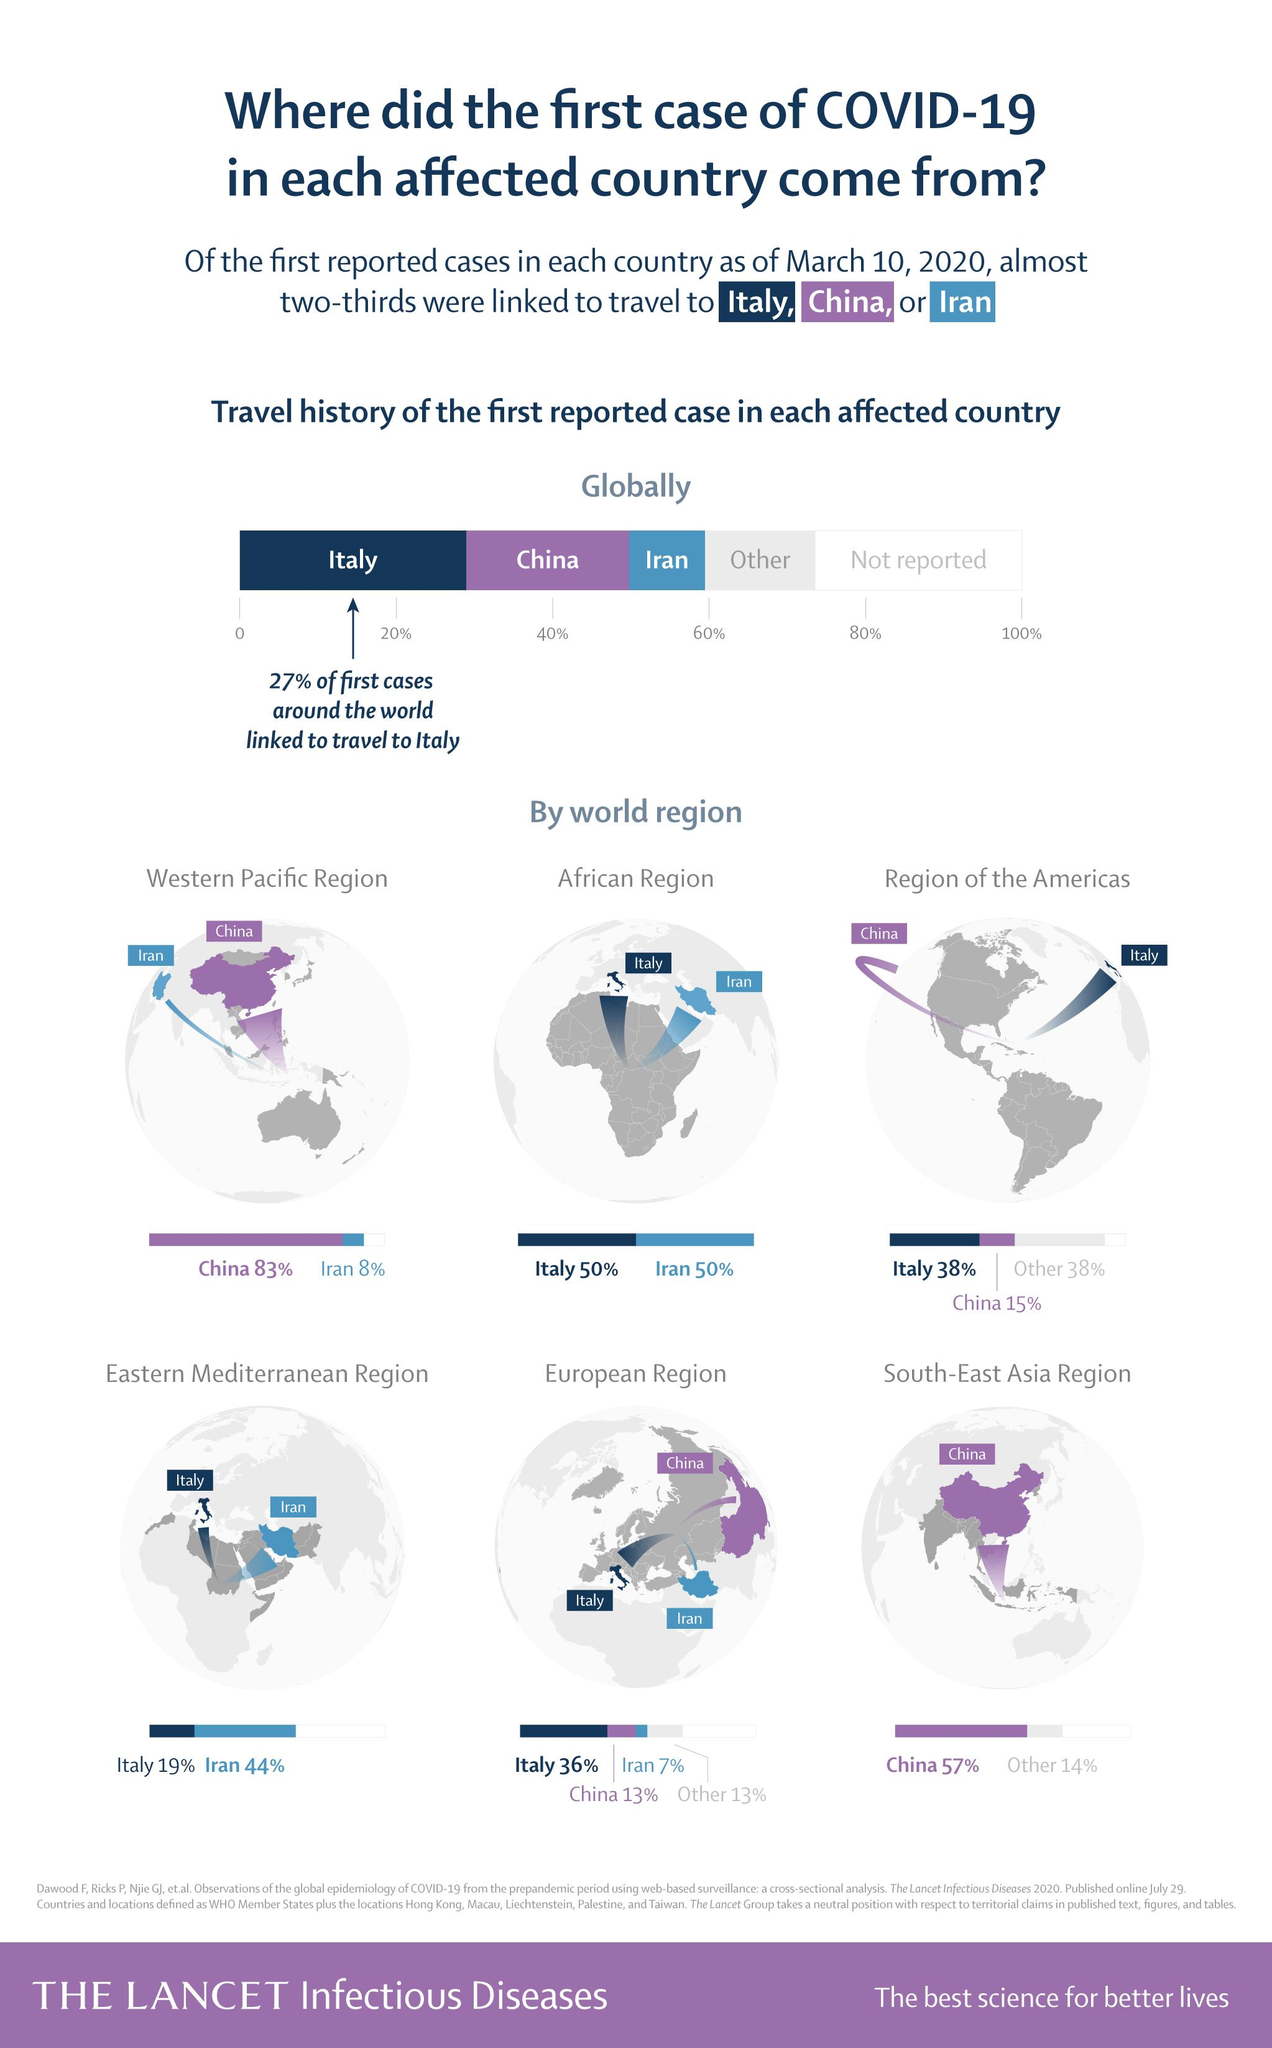Give some essential details in this illustration. A significant percentage of individuals in the African region have been affected by COVID-19 due to traveling to Italy. In the European region, a significant percentage of individuals are affected by COVID-19 due to traveling to Iran, with estimates suggesting that approximately 7% of individuals in the region have been infected with the virus as a result of travel to the country. It is reported that approximately 27% of individuals who have been affected by COVID-19 have done so due to travel to Italy. A significant proportion of individuals in the Western Pacific region have been impacted by COVID-19 due to travel to China, with approximately 83% reporting cases. 